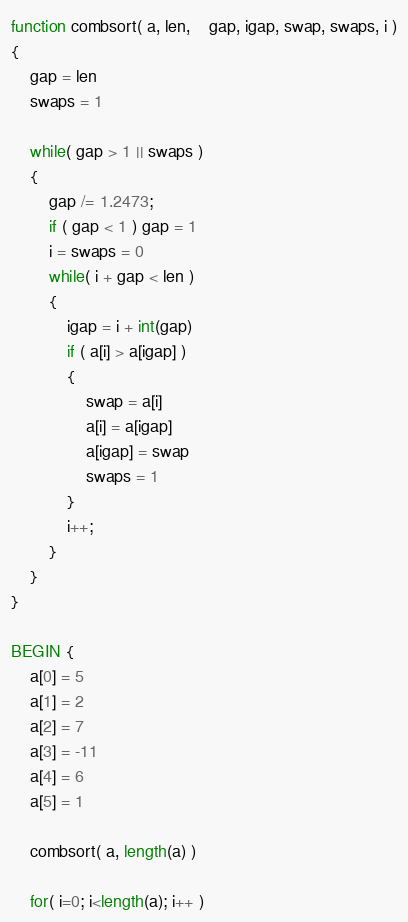<code> <loc_0><loc_0><loc_500><loc_500><_Awk_>function combsort( a, len,    gap, igap, swap, swaps, i )
{
	gap = len
	swaps = 1
	
	while( gap > 1 || swaps )
	{
		gap /= 1.2473;
		if ( gap < 1 ) gap = 1
		i = swaps = 0
		while( i + gap < len )
		{
			igap = i + int(gap)
			if ( a[i] > a[igap] )
			{
				swap = a[i]
				a[i] = a[igap]
				a[igap] = swap
				swaps = 1
			}
			i++;
		}		
	}
}

BEGIN {
	a[0] = 5
	a[1] = 2
	a[2] = 7
	a[3] = -11
	a[4] = 6
	a[5] = 1
	
	combsort( a, length(a) )
	
	for( i=0; i<length(a); i++ )</code> 